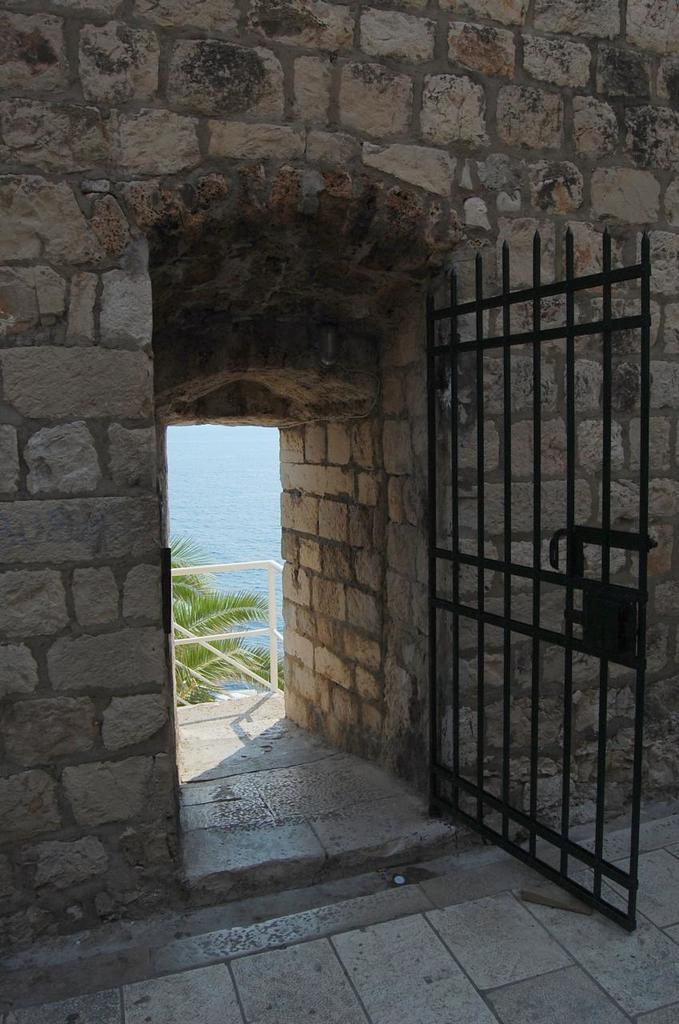What structure is present in the image? There is a gate in the image. How is the gate connected to another structure? The gate is attached to a wall. What type of natural vegetation is visible in the image? There are trees visible in the image. How many bikes are parked near the gate in the image? There are no bikes present in the image. What type of grape is growing on the trees in the image? There are no grapes present in the image; it only features trees. 